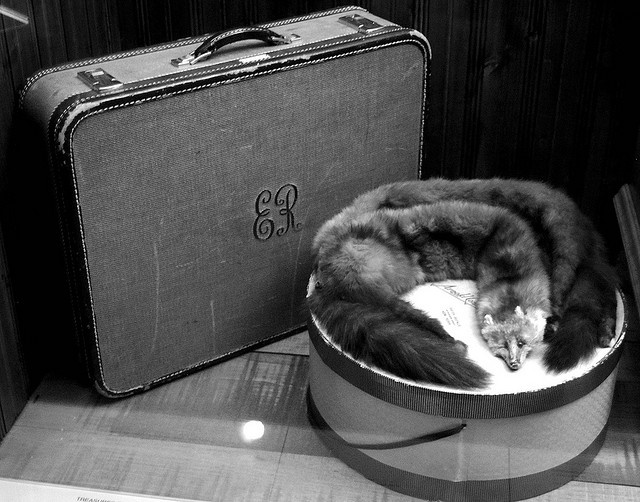Describe the objects in this image and their specific colors. I can see a suitcase in black, gray, darkgray, and lightgray tones in this image. 